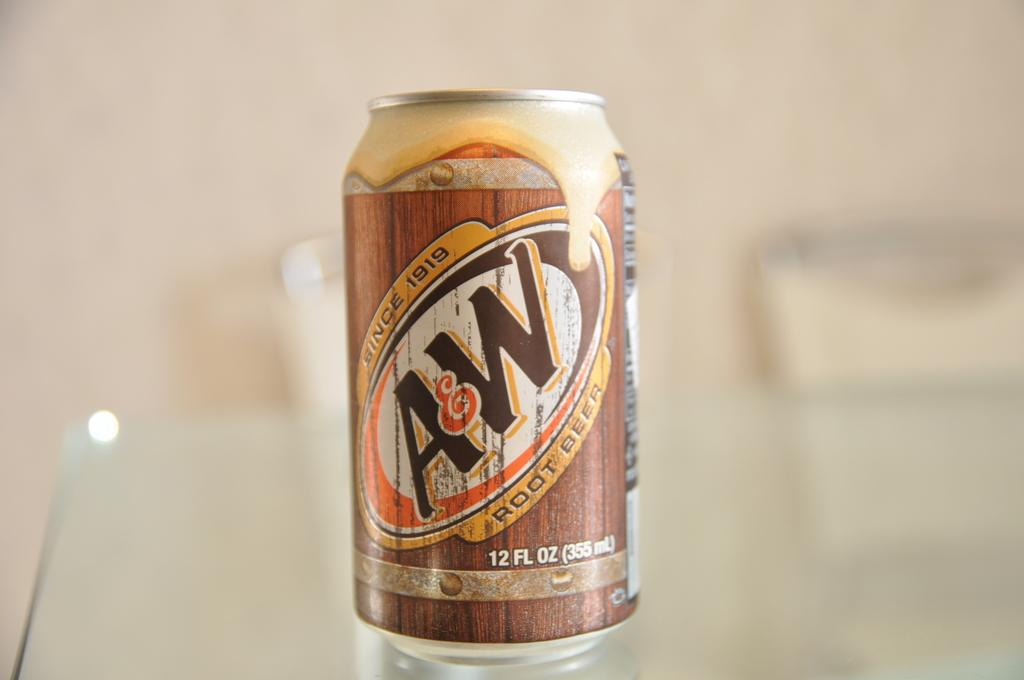<image>
Offer a succinct explanation of the picture presented. The can of A&W root beer mentions that they have been around since 1919. 